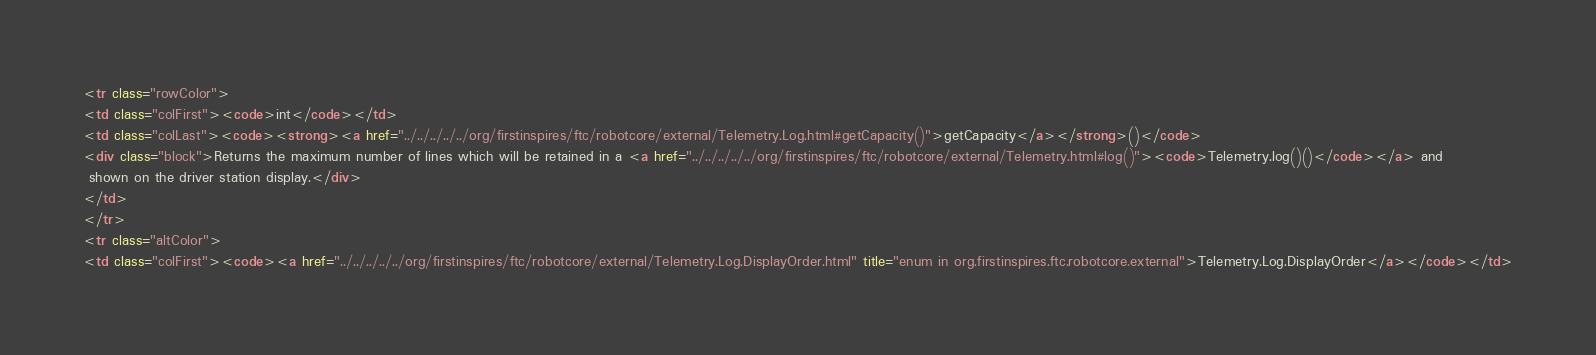<code> <loc_0><loc_0><loc_500><loc_500><_HTML_><tr class="rowColor">
<td class="colFirst"><code>int</code></td>
<td class="colLast"><code><strong><a href="../../../../../org/firstinspires/ftc/robotcore/external/Telemetry.Log.html#getCapacity()">getCapacity</a></strong>()</code>
<div class="block">Returns the maximum number of lines which will be retained in a <a href="../../../../../org/firstinspires/ftc/robotcore/external/Telemetry.html#log()"><code>Telemetry.log()()</code></a> and
 shown on the driver station display.</div>
</td>
</tr>
<tr class="altColor">
<td class="colFirst"><code><a href="../../../../../org/firstinspires/ftc/robotcore/external/Telemetry.Log.DisplayOrder.html" title="enum in org.firstinspires.ftc.robotcore.external">Telemetry.Log.DisplayOrder</a></code></td></code> 